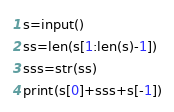<code> <loc_0><loc_0><loc_500><loc_500><_Python_>s=input()
ss=len(s[1:len(s)-1])
sss=str(ss)
print(s[0]+sss+s[-1])</code> 